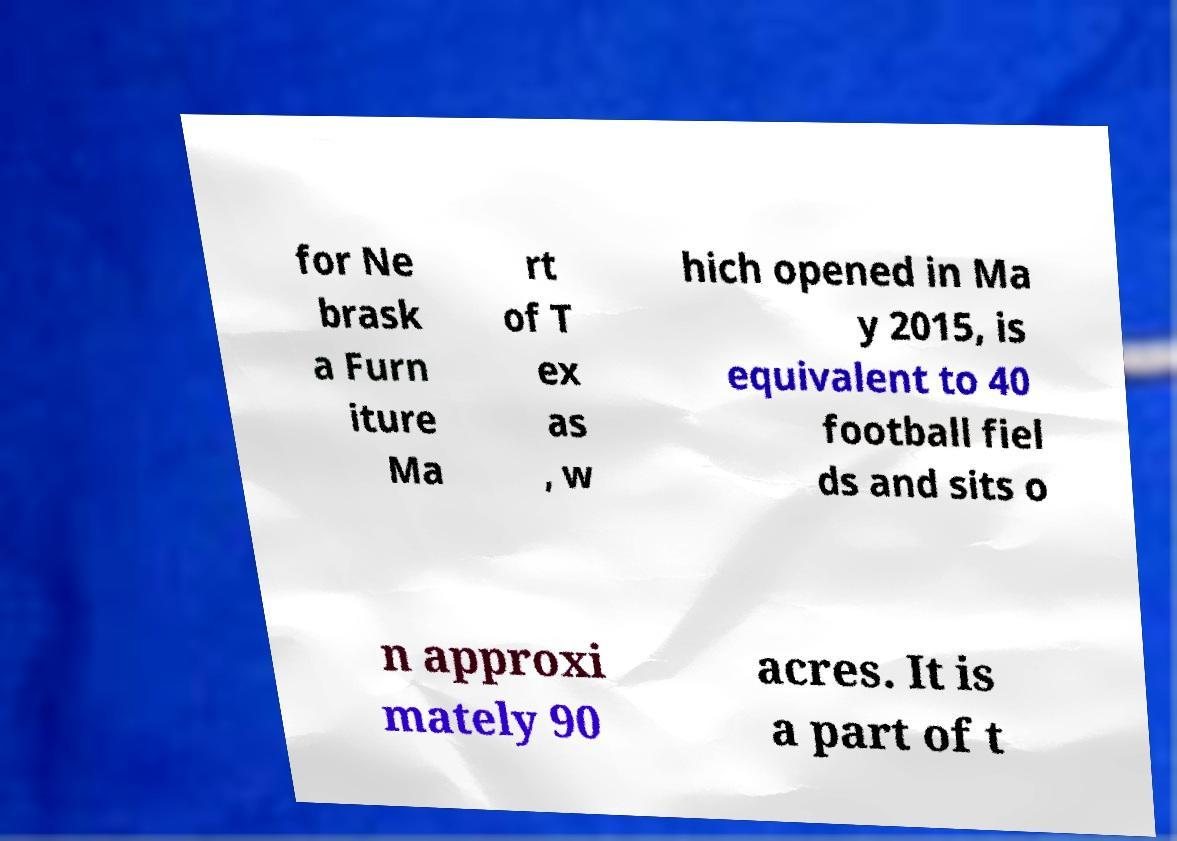Could you assist in decoding the text presented in this image and type it out clearly? for Ne brask a Furn iture Ma rt of T ex as , w hich opened in Ma y 2015, is equivalent to 40 football fiel ds and sits o n approxi mately 90 acres. It is a part of t 